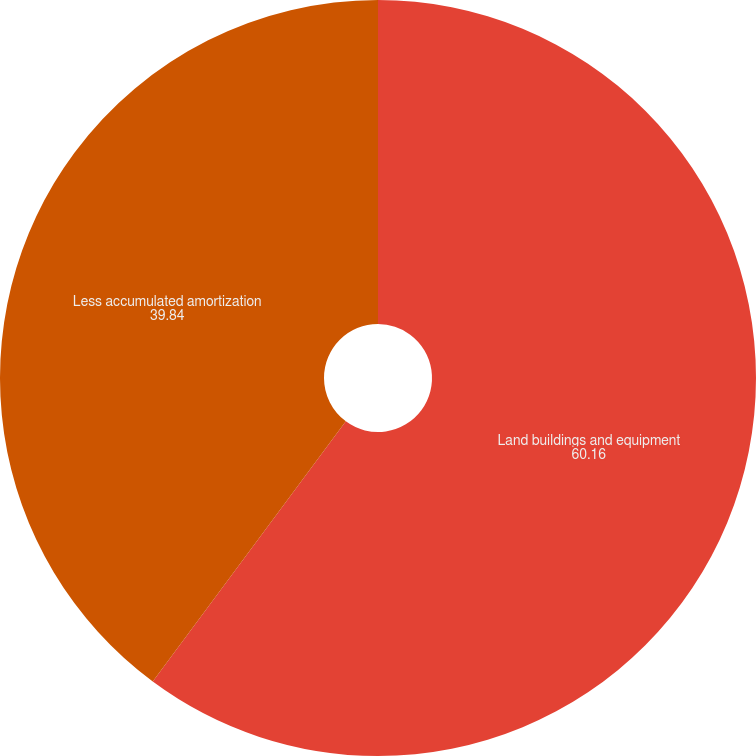Convert chart to OTSL. <chart><loc_0><loc_0><loc_500><loc_500><pie_chart><fcel>Land buildings and equipment<fcel>Less accumulated amortization<nl><fcel>60.16%<fcel>39.84%<nl></chart> 